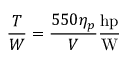<formula> <loc_0><loc_0><loc_500><loc_500>{ \frac { T } { W } } = { \frac { 5 5 0 \eta _ { p } } { V } } { \frac { h p } { W } }</formula> 